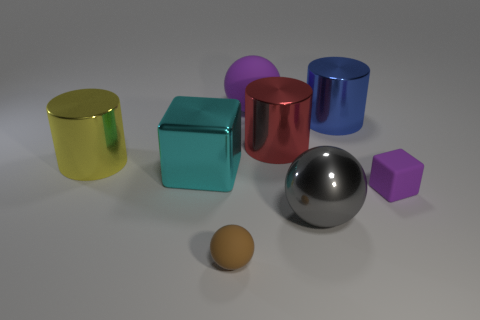Add 1 metal blocks. How many objects exist? 9 Subtract all spheres. How many objects are left? 5 Add 3 small purple things. How many small purple things are left? 4 Add 6 small matte objects. How many small matte objects exist? 8 Subtract 1 gray spheres. How many objects are left? 7 Subtract all small purple shiny spheres. Subtract all big purple spheres. How many objects are left? 7 